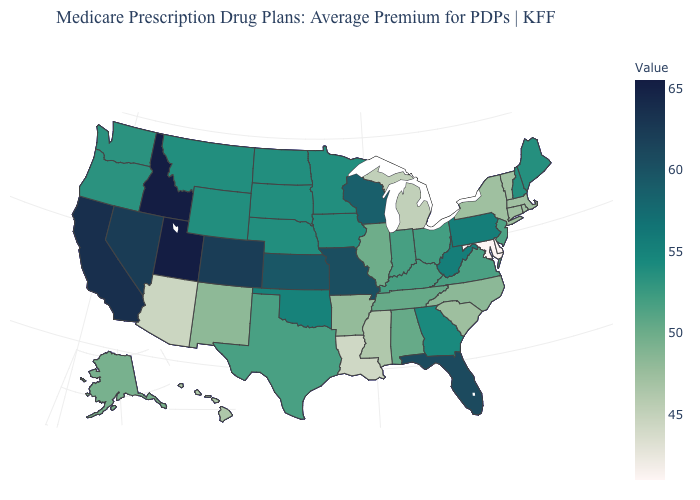Which states hav the highest value in the West?
Give a very brief answer. Idaho, Utah. Which states have the highest value in the USA?
Quick response, please. Idaho, Utah. Does New York have the lowest value in the Northeast?
Short answer required. No. Does Pennsylvania have the highest value in the Northeast?
Short answer required. Yes. Which states have the lowest value in the South?
Keep it brief. Delaware, Maryland. 